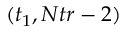<formula> <loc_0><loc_0><loc_500><loc_500>( t _ { 1 } , N t r - 2 )</formula> 